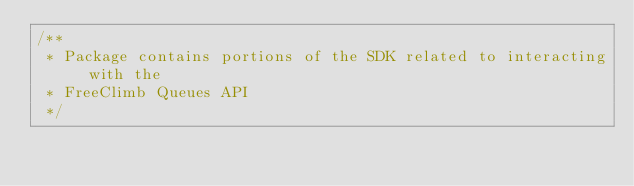<code> <loc_0><loc_0><loc_500><loc_500><_Java_>/**
 * Package contains portions of the SDK related to interacting with the
 * FreeClimb Queues API
 */</code> 